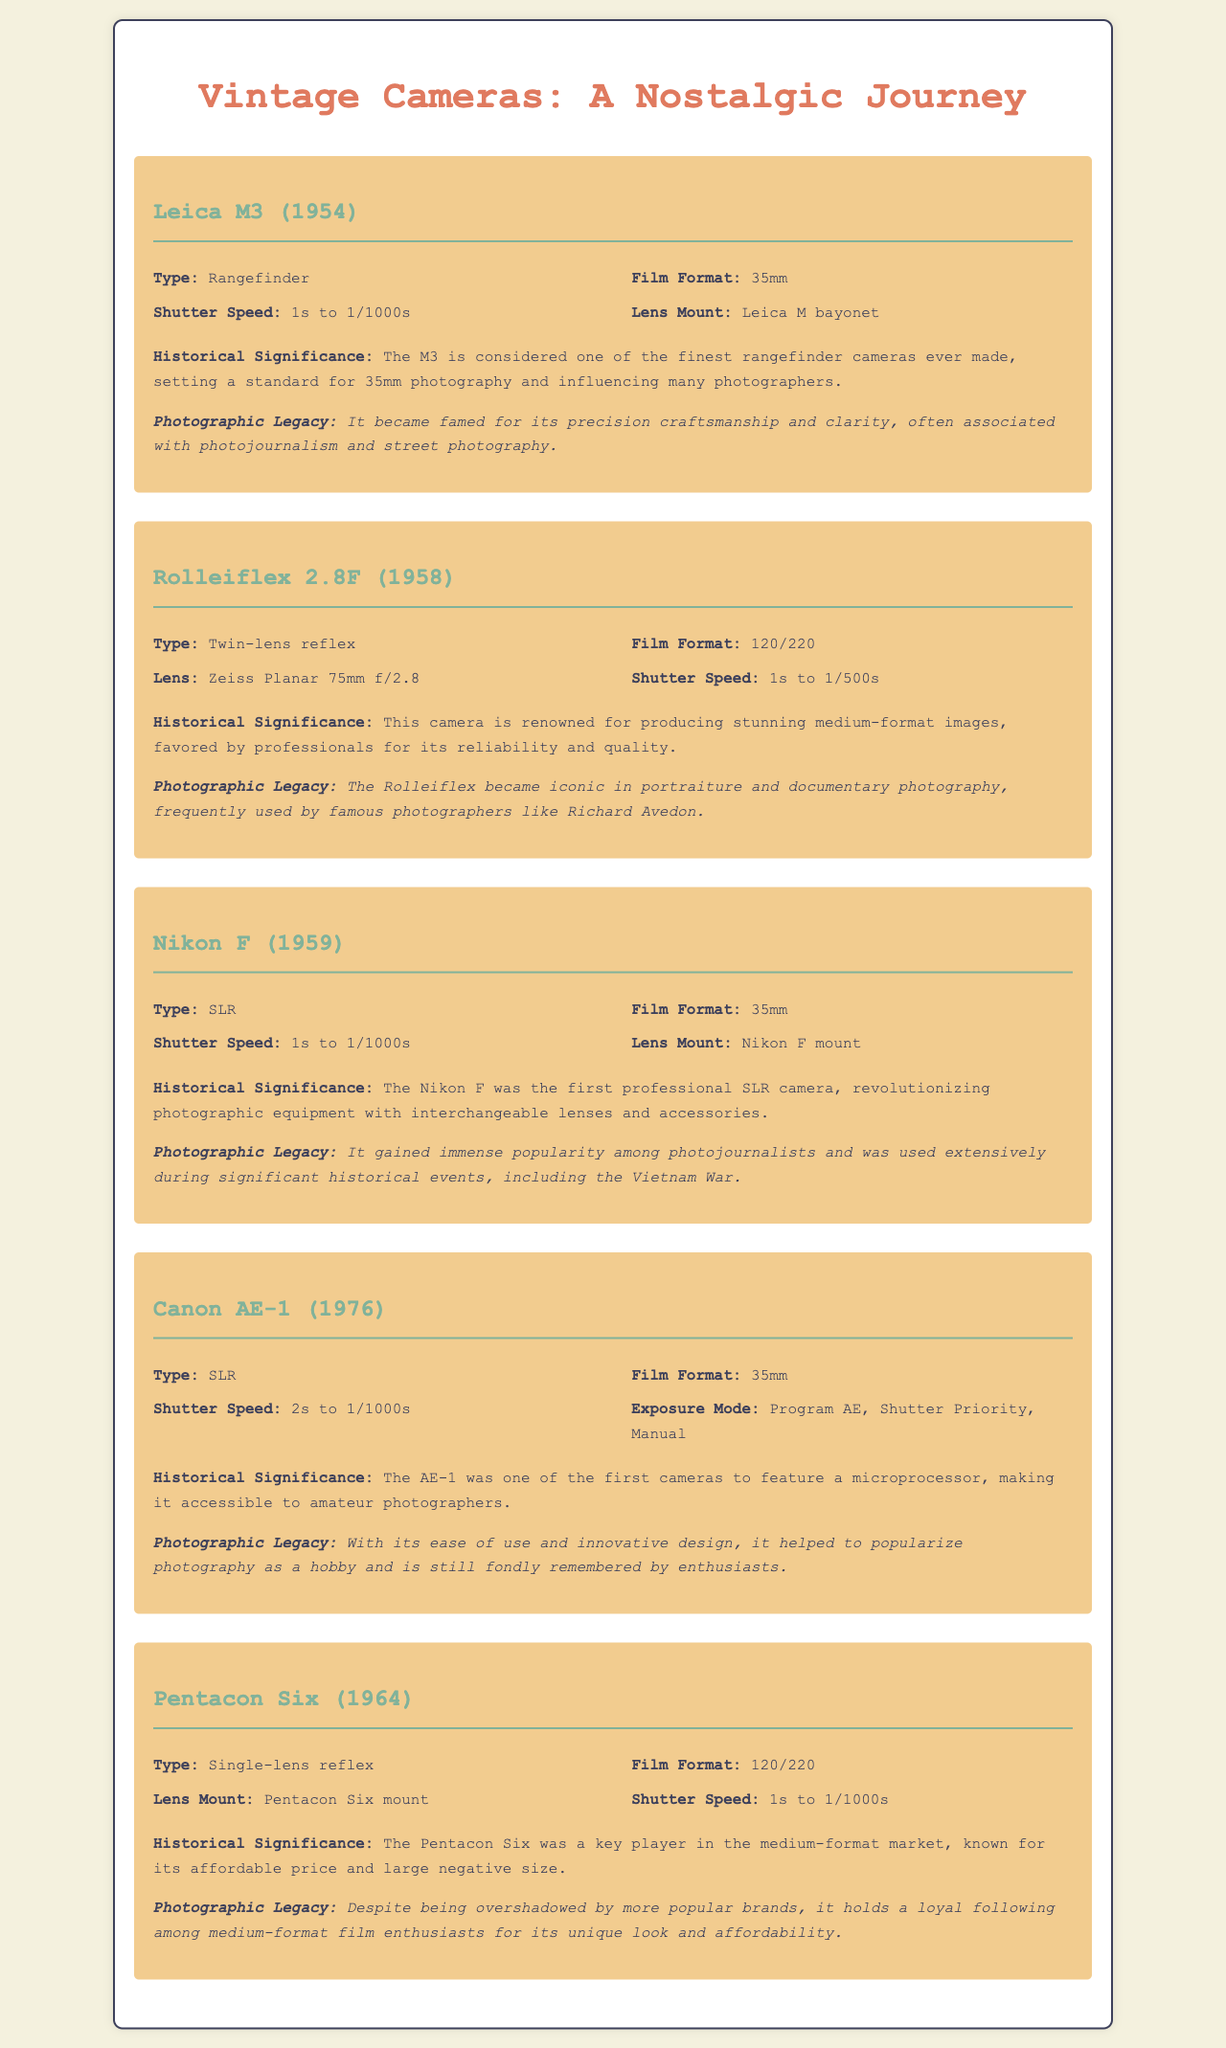what year was the Leica M3 released? The document states that the Leica M3 was released in 1954.
Answer: 1954 what type of camera is the Rolleiflex 2.8F? The document indicates that the Rolleiflex 2.8F is a Twin-lens reflex camera.
Answer: Twin-lens reflex what is the film format for the Nikon F? The Nikon F uses the 35mm film format as mentioned in the document.
Answer: 35mm how many shutter speeds does the Canon AE-1 have? The document shows that the Canon AE-1 has shutter speeds ranging from 2s to 1/1000s.
Answer: 2s to 1/1000s which camera is associated with Richard Avedon? The document notes that the Rolleiflex became iconic in portraiture and is frequently used by Richard Avedon.
Answer: Rolleiflex 2.8F what lens is included with the Rolleiflex 2.8F? The lens mentioned for the Rolleiflex 2.8F is the Zeiss Planar 75mm f/2.8.
Answer: Zeiss Planar 75mm f/2.8 what is significant about the Nikon F in photography history? The document states that it was the first professional SLR camera.
Answer: First professional SLR which camera helped popularize photography as a hobby? According to the document, the Canon AE-1 helped to popularize photography.
Answer: Canon AE-1 what type of mount does the Pentacon Six use? The Pentacon Six uses the Pentacon Six mount as specified in the document.
Answer: Pentacon Six mount 